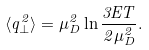<formula> <loc_0><loc_0><loc_500><loc_500>\langle q ^ { 2 } _ { \perp } \rangle = \mu _ { D } ^ { 2 } \ln \frac { 3 E T } { 2 \mu _ { D } ^ { 2 } } .</formula> 